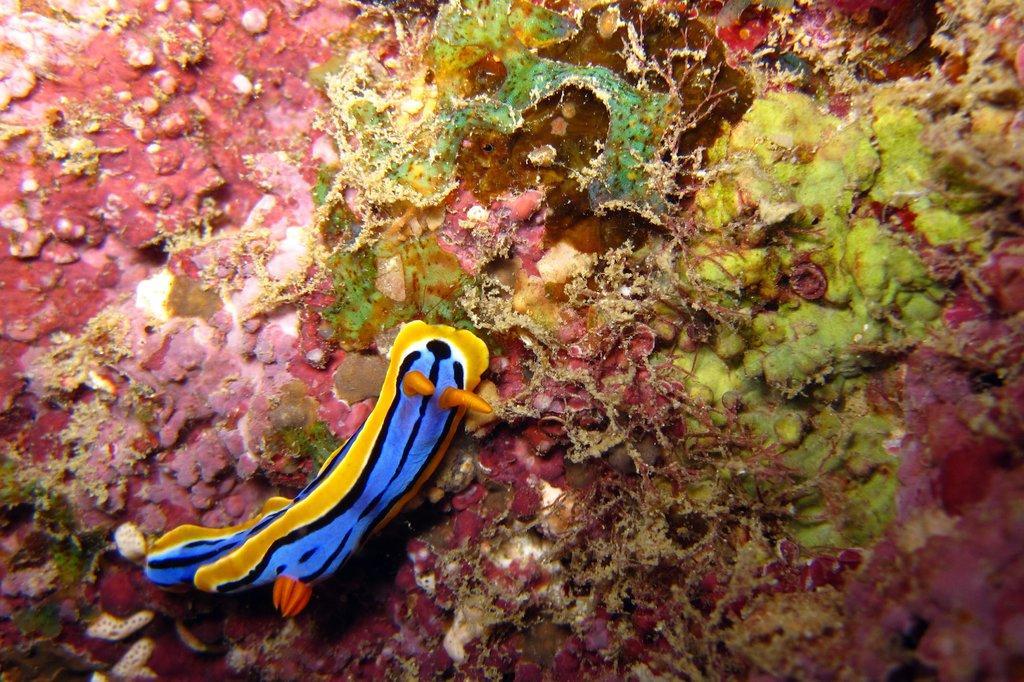Can you describe this image briefly? In this image there is a snail and in the background there are sea plants. 